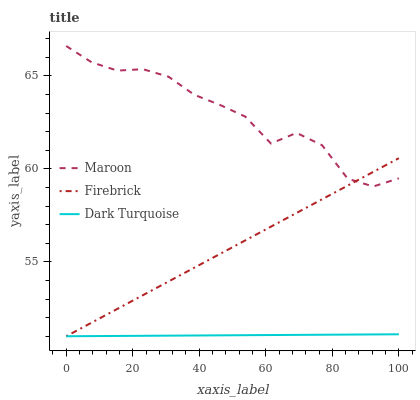Does Dark Turquoise have the minimum area under the curve?
Answer yes or no. Yes. Does Maroon have the maximum area under the curve?
Answer yes or no. Yes. Does Firebrick have the minimum area under the curve?
Answer yes or no. No. Does Firebrick have the maximum area under the curve?
Answer yes or no. No. Is Firebrick the smoothest?
Answer yes or no. Yes. Is Maroon the roughest?
Answer yes or no. Yes. Is Maroon the smoothest?
Answer yes or no. No. Is Firebrick the roughest?
Answer yes or no. No. Does Dark Turquoise have the lowest value?
Answer yes or no. Yes. Does Maroon have the lowest value?
Answer yes or no. No. Does Maroon have the highest value?
Answer yes or no. Yes. Does Firebrick have the highest value?
Answer yes or no. No. Is Dark Turquoise less than Maroon?
Answer yes or no. Yes. Is Maroon greater than Dark Turquoise?
Answer yes or no. Yes. Does Dark Turquoise intersect Firebrick?
Answer yes or no. Yes. Is Dark Turquoise less than Firebrick?
Answer yes or no. No. Is Dark Turquoise greater than Firebrick?
Answer yes or no. No. Does Dark Turquoise intersect Maroon?
Answer yes or no. No. 